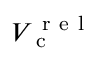Convert formula to latex. <formula><loc_0><loc_0><loc_500><loc_500>V _ { c } ^ { r e l }</formula> 